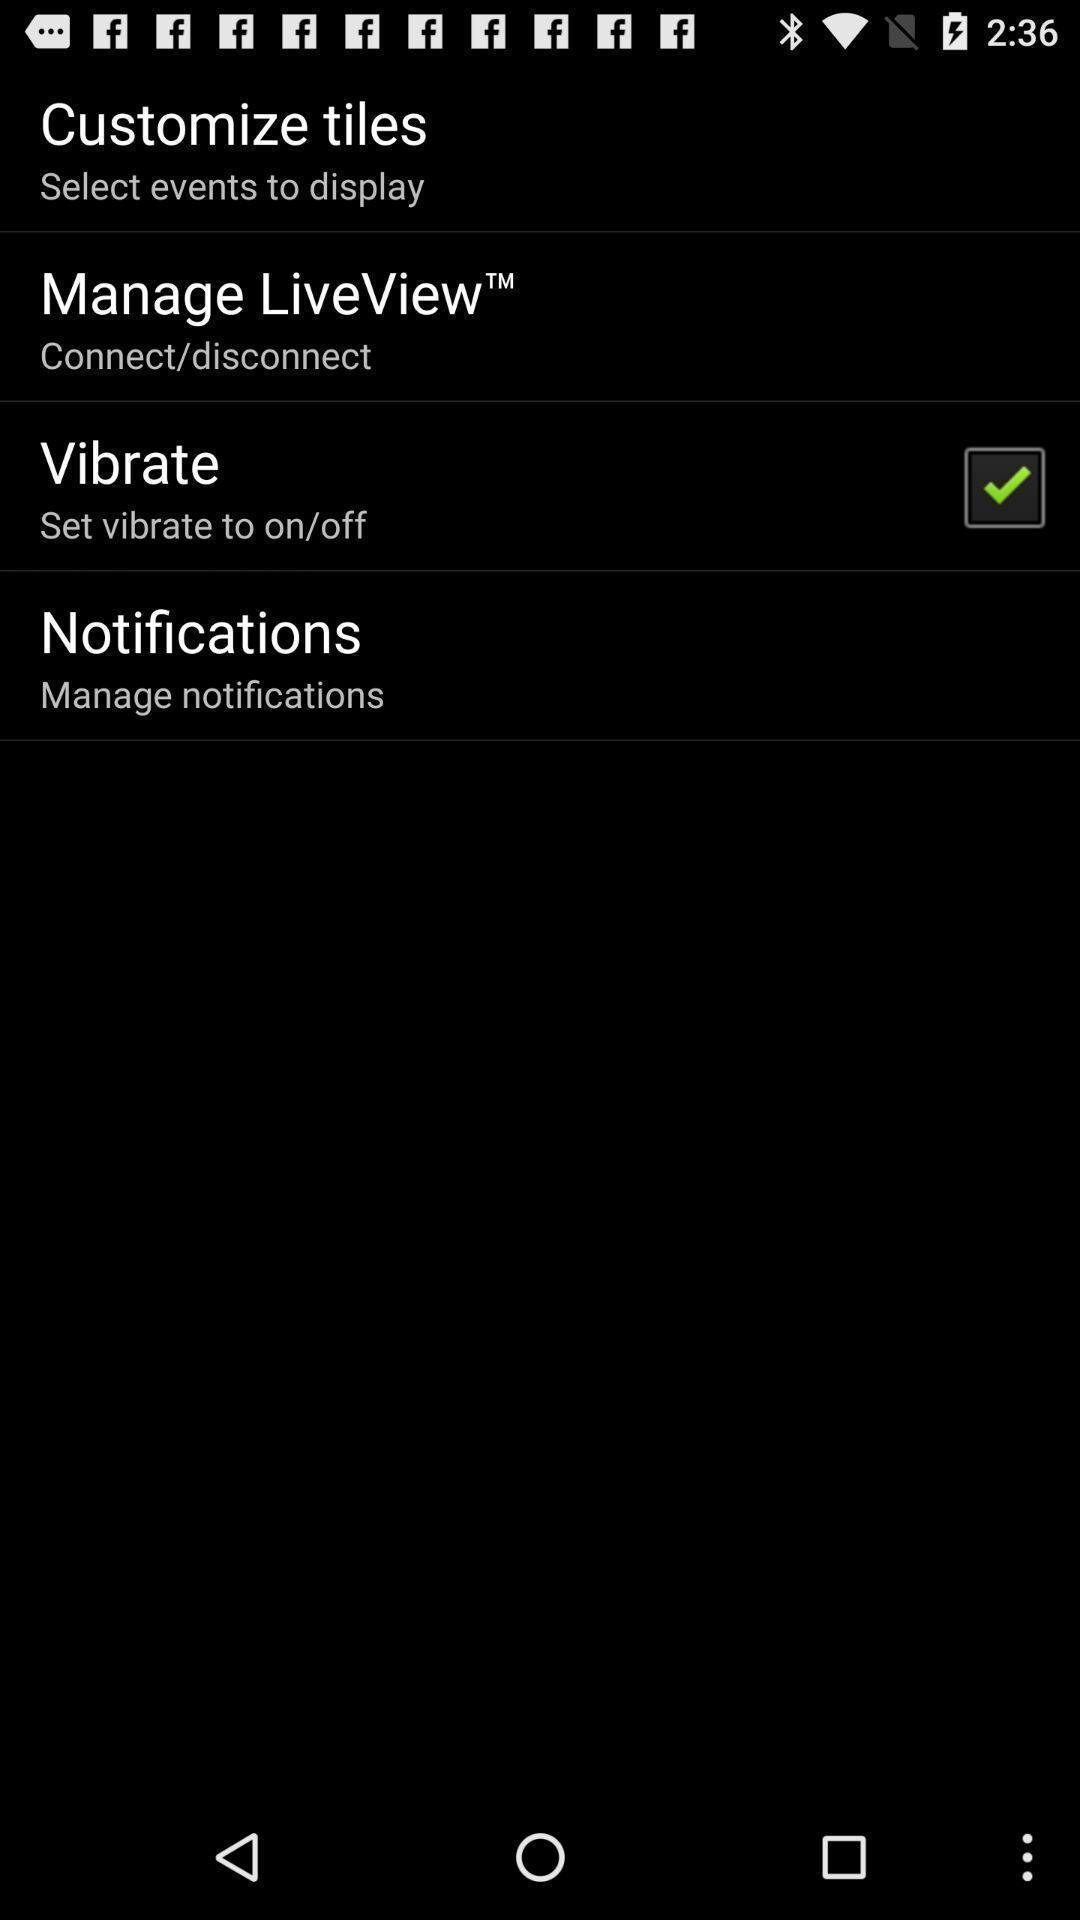Describe the key features of this screenshot. Settings page for the appearance launcher app. 